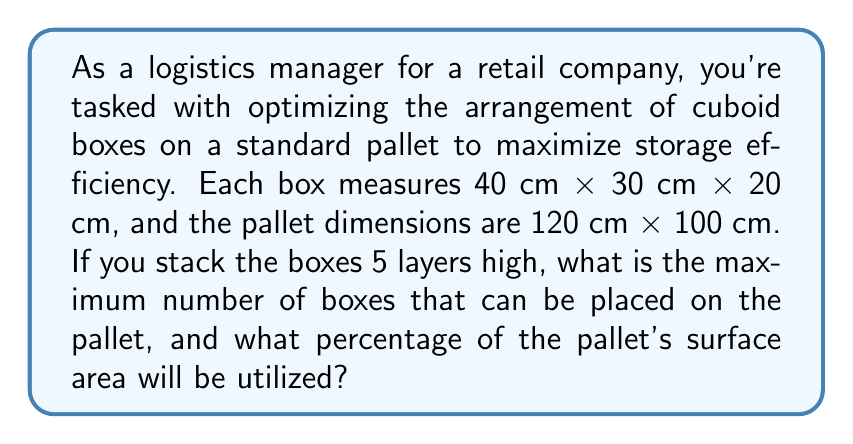Can you answer this question? Let's approach this problem step-by-step:

1. Determine possible arrangements of boxes on the pallet:
   a) Long side (40 cm) along the 120 cm side of the pallet:
      $\lfloor 120 \div 40 \rfloor = 3$ boxes
      $\lfloor 100 \div 30 \rfloor = 3$ boxes
   b) Short side (30 cm) along the 120 cm side of the pallet:
      $\lfloor 120 \div 30 \rfloor = 4$ boxes
      $\lfloor 100 \div 40 \rfloor = 2$ boxes

2. Calculate the number of boxes per layer:
   a) 3 × 3 = 9 boxes
   b) 4 × 2 = 8 boxes
   The optimal arrangement is 3 × 3 = 9 boxes per layer.

3. Calculate the total number of boxes for 5 layers:
   $9 \times 5 = 45$ boxes

4. Calculate the surface area utilized:
   Area of pallet = 120 cm × 100 cm = 12,000 cm²
   Area occupied by boxes = 9 × (40 cm × 30 cm) = 10,800 cm²
   
5. Calculate the percentage of surface area utilized:
   $$\text{Utilization} = \frac{\text{Area occupied}}{\text{Total area}} \times 100\%$$
   $$= \frac{10,800}{12,000} \times 100\% = 90\%$$
Answer: The maximum number of boxes that can be placed on the pallet is 45, and 90% of the pallet's surface area will be utilized. 